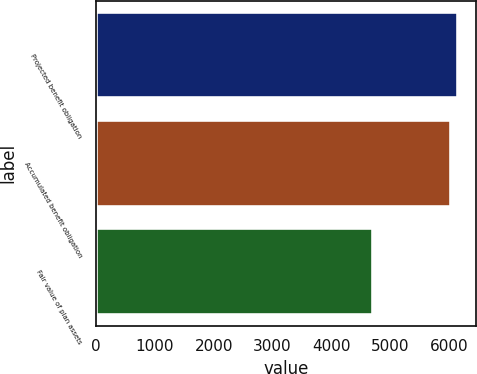Convert chart to OTSL. <chart><loc_0><loc_0><loc_500><loc_500><bar_chart><fcel>Projected benefit obligation<fcel>Accumulated benefit obligation<fcel>Fair value of plan assets<nl><fcel>6155.8<fcel>6024<fcel>4707<nl></chart> 